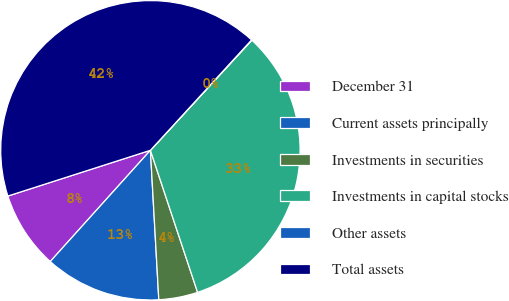Convert chart to OTSL. <chart><loc_0><loc_0><loc_500><loc_500><pie_chart><fcel>December 31<fcel>Current assets principally<fcel>Investments in securities<fcel>Investments in capital stocks<fcel>Other assets<fcel>Total assets<nl><fcel>8.39%<fcel>12.56%<fcel>4.21%<fcel>33.05%<fcel>0.04%<fcel>41.75%<nl></chart> 